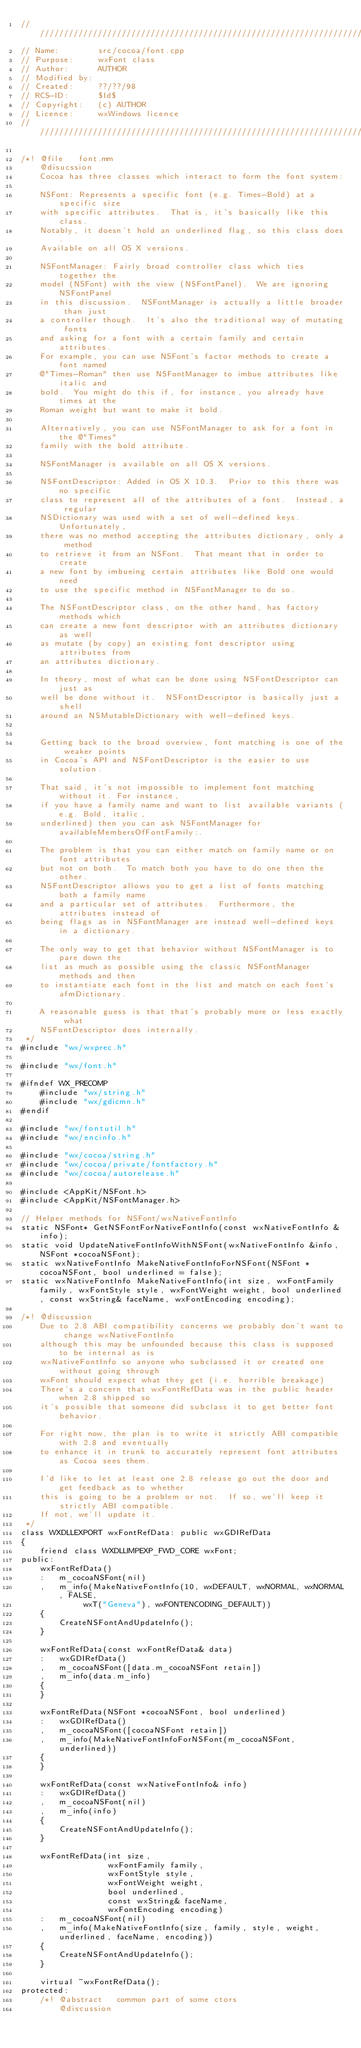<code> <loc_0><loc_0><loc_500><loc_500><_ObjectiveC_>/////////////////////////////////////////////////////////////////////////////
// Name:        src/cocoa/font.cpp
// Purpose:     wxFont class
// Author:      AUTHOR
// Modified by:
// Created:     ??/??/98
// RCS-ID:      $Id$
// Copyright:   (c) AUTHOR
// Licence:     wxWindows licence
/////////////////////////////////////////////////////////////////////////////

/*! @file   font.mm
    @disucssion
    Cocoa has three classes which interact to form the font system:

    NSFont: Represents a specific font (e.g. Times-Bold) at a specific size
    with specific attributes.  That is, it's basically like this class.
    Notably, it doesn't hold an underlined flag, so this class does.
    Available on all OS X versions.

    NSFontManager: Fairly broad controller class which ties together the
    model (NSFont) with the view (NSFontPanel).  We are ignoring NSFontPanel
    in this discussion.  NSFontManager is actually a little broader than just
    a controller though.  It's also the traditional way of mutating fonts
    and asking for a font with a certain family and certain attributes.
    For example, you can use NSFont's factor methods to create a font named
    @"Times-Roman" then use NSFontManager to imbue attributes like italic and
    bold.  You might do this if, for instance, you already have times at the
    Roman weight but want to make it bold.

    Alternatively, you can use NSFontManager to ask for a font in the @"Times"
    family with the bold attribute.

    NSFontManager is available on all OS X versions.

    NSFontDescriptor: Added in OS X 10.3.  Prior to this there was no specific
    class to represent all of the attributes of a font.  Instead, a regular
    NSDictionary was used with a set of well-defined keys.  Unfortunately,
    there was no method accepting the attributes dictionary, only a method
    to retrieve it from an NSFont.  That meant that in order to create
    a new font by imbueing certain attributes like Bold one would need
    to use the specific method in NSFontManager to do so.

    The NSFontDescriptor class, on the other hand, has factory methods which
    can create a new font descriptor with an attributes dictionary as well
    as mutate (by copy) an existing font descriptor using attributes from
    an attributes dictionary.

    In theory, most of what can be done using NSFontDescriptor can just as
    well be done without it.  NSFontDescriptor is basically just a shell
    around an NSMutableDictionary with well-defined keys.


    Getting back to the broad overview, font matching is one of the weaker points
    in Cocoa's API and NSFontDescriptor is the easier to use solution.

    That said, it's not impossible to implement font matching without it. For instance,
    if you have a family name and want to list available variants (e.g. Bold, italic,
    underlined) then you can ask NSFontManager for availableMembersOfFontFamily:.

    The problem is that you can either match on family name or on font attributes
    but not on both.  To match both you have to do one then the other.
    NSFontDescriptor allows you to get a list of fonts matching both a family name
    and a particular set of attributes.  Furthermore, the attributes instead of
    being flags as in NSFontManager are instead well-defined keys in a dictionary.

    The only way to get that behavior without NSFontManager is to pare down the
    list as much as possible using the classic NSFontManager methods and then
    to instantiate each font in the list and match on each font's afmDictionary.

    A reasonable guess is that that's probably more or less exactly what
    NSFontDescriptor does internally.
 */
#include "wx/wxprec.h"

#include "wx/font.h"

#ifndef WX_PRECOMP
    #include "wx/string.h"
    #include "wx/gdicmn.h"
#endif

#include "wx/fontutil.h"
#include "wx/encinfo.h"

#include "wx/cocoa/string.h"
#include "wx/cocoa/private/fontfactory.h"
#include "wx/cocoa/autorelease.h"

#include <AppKit/NSFont.h>
#include <AppKit/NSFontManager.h>

// Helper methods for NSFont/wxNativeFontInfo
static NSFont* GetNSFontForNativeFontInfo(const wxNativeFontInfo &info);
static void UpdateNativeFontInfoWithNSFont(wxNativeFontInfo &info, NSFont *cocoaNSFont);
static wxNativeFontInfo MakeNativeFontInfoForNSFont(NSFont *cocoaNSFont, bool underlined = false);
static wxNativeFontInfo MakeNativeFontInfo(int size, wxFontFamily family, wxFontStyle style, wxFontWeight weight, bool underlined, const wxString& faceName, wxFontEncoding encoding);

/*! @discussion
    Due to 2.8 ABI compatibility concerns we probably don't want to change wxNativeFontInfo
    although this may be unfounded because this class is supposed to be internal as is
    wxNativeFontInfo so anyone who subclassed it or created one without going through
    wxFont should expect what they get (i.e. horrible breakage)
    There's a concern that wxFontRefData was in the public header when 2.8 shipped so
    it's possible that someone did subclass it to get better font behavior.

    For right now, the plan is to write it strictly ABI compatible with 2.8 and eventually
    to enhance it in trunk to accurately represent font attributes as Cocoa sees them.

    I'd like to let at least one 2.8 release go out the door and get feedback as to whether
    this is going to be a problem or not.  If so, we'll keep it strictly ABI compatible.
    If not, we'll update it.
 */
class WXDLLEXPORT wxFontRefData: public wxGDIRefData
{
    friend class WXDLLIMPEXP_FWD_CORE wxFont;
public:
    wxFontRefData()
    :   m_cocoaNSFont(nil)
    ,   m_info(MakeNativeFontInfo(10, wxDEFAULT, wxNORMAL, wxNORMAL, FALSE,
             wxT("Geneva"), wxFONTENCODING_DEFAULT))
    {
        CreateNSFontAndUpdateInfo();
    }

    wxFontRefData(const wxFontRefData& data)
    :   wxGDIRefData()
    ,   m_cocoaNSFont([data.m_cocoaNSFont retain])
    ,   m_info(data.m_info)
    {
    }

    wxFontRefData(NSFont *cocoaNSFont, bool underlined)
    :   wxGDIRefData()
    ,   m_cocoaNSFont([cocoaNSFont retain])
    ,   m_info(MakeNativeFontInfoForNSFont(m_cocoaNSFont, underlined))
    {
    }

    wxFontRefData(const wxNativeFontInfo& info)
    :   wxGDIRefData()
    ,   m_cocoaNSFont(nil)
    ,   m_info(info)
    {
        CreateNSFontAndUpdateInfo();
    }

    wxFontRefData(int size,
                  wxFontFamily family,
                  wxFontStyle style,
                  wxFontWeight weight,
                  bool underlined,
                  const wxString& faceName,
                  wxFontEncoding encoding)
    :   m_cocoaNSFont(nil)
    ,   m_info(MakeNativeFontInfo(size, family, style, weight, underlined, faceName, encoding))
    {
        CreateNSFontAndUpdateInfo();
    }

    virtual ~wxFontRefData();
protected:
    /*! @abstract   common part of some ctors
        @discussion</code> 